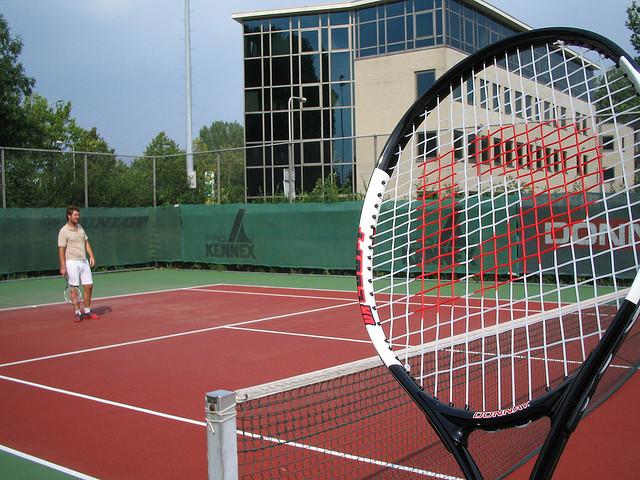What color is the court?
Quick response, please. Red. Who is holding the racket?
Write a very short answer. Photographer. How is the building designed?
Quick response, please. Glass. 